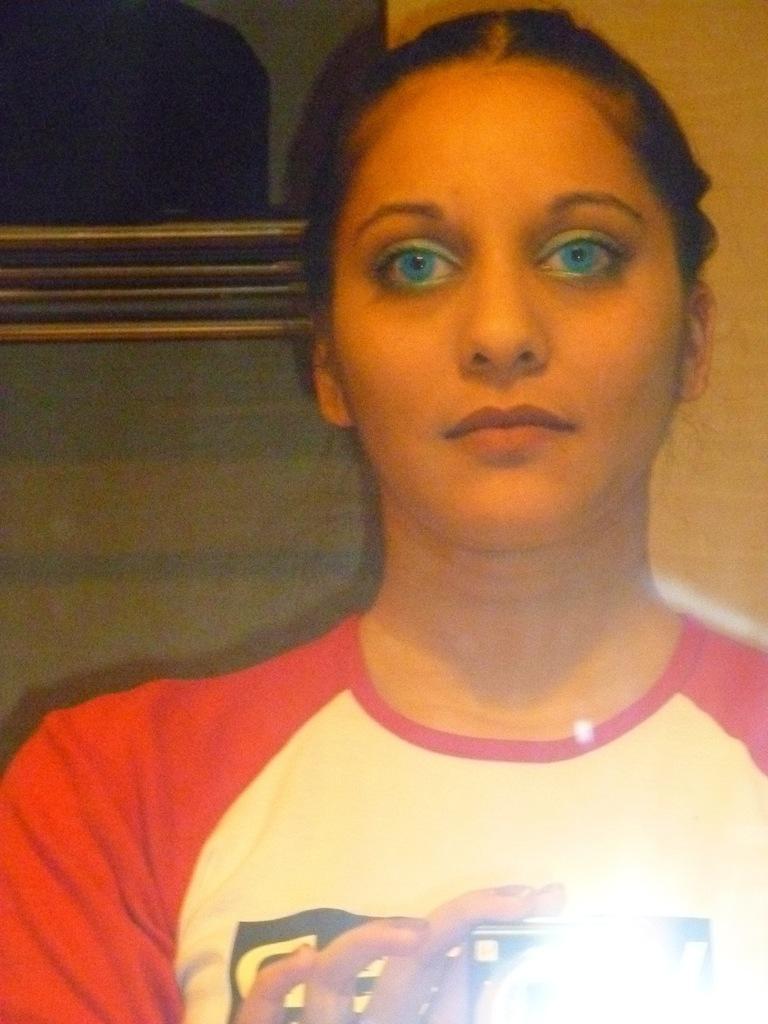How would you summarize this image in a sentence or two? In this picture I can see a woman who is wearing a t-shirt and I see that she is holding a camera and I can see the light on the bottom right of this image. 